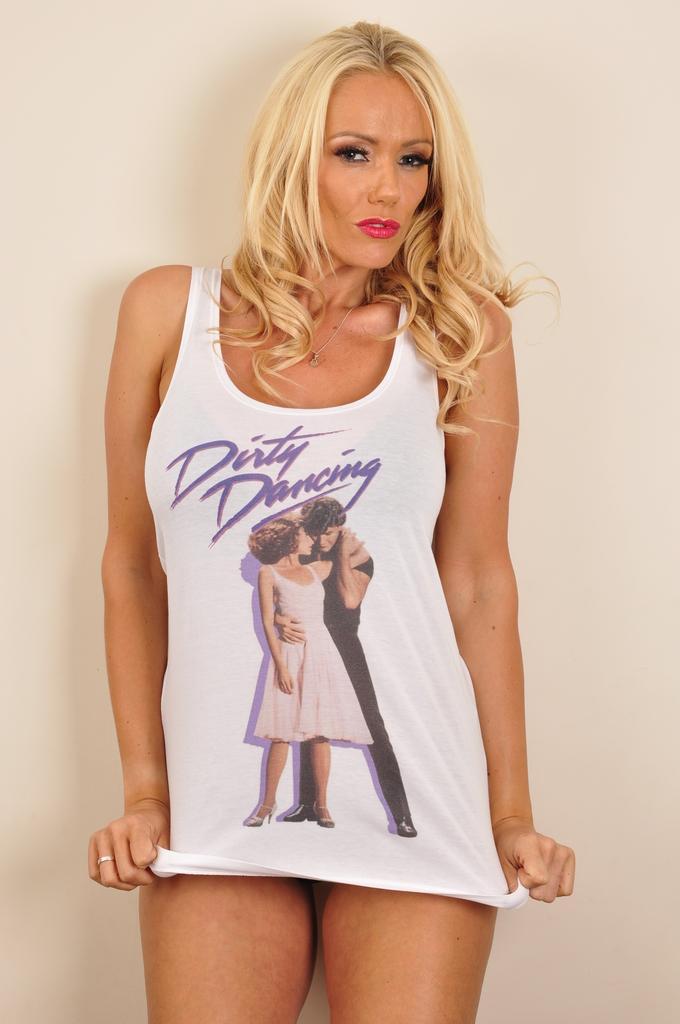Could you give a brief overview of what you see in this image? In this picture, we see the woman in white T-shirt is standing. He is posing for the photo. In the background, it is white in color. 